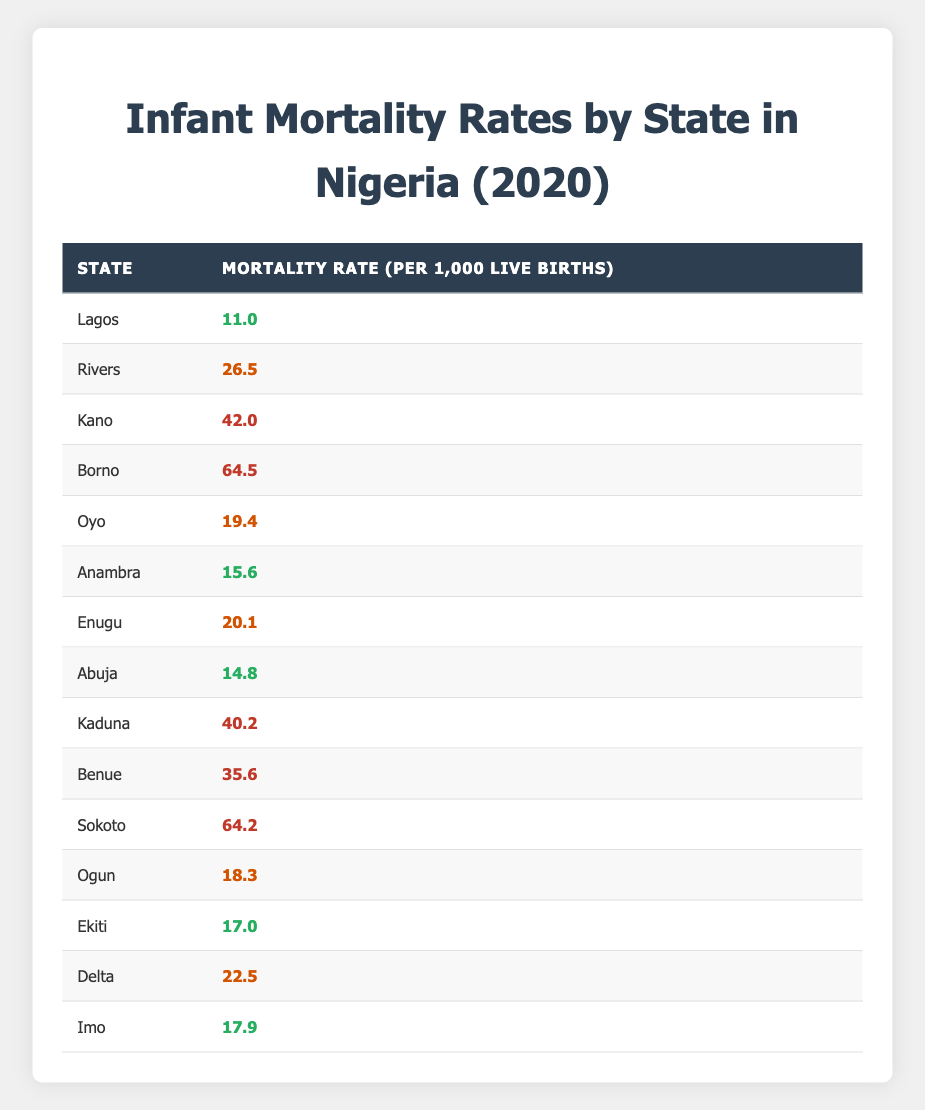What is the infant mortality rate in Lagos? The table shows that the mortality rate for Lagos is listed as 11.0 per 1,000 live births.
Answer: 11.0 Which state has the highest infant mortality rate? The state with the highest mortality rate is Borno, with a rate of 64.5 per 1,000 live births.
Answer: Borno What is the infant mortality rate of Rivers compared to Kaduna? Rivers has a mortality rate of 26.5, while Kaduna has a higher rate of 40.2. Thus, Kaduna's rate is higher than Rivers'.
Answer: Higher What is the difference between the infant mortality rates of Anambra and Ekiti? Anambra's rate is 15.6, and Ekiti's rate is 17.0. The difference is 17.0 - 15.6 = 1.4.
Answer: 1.4 How many states have a mortality rate above 40? The states with a mortality rate above 40 are Kano, Borno, Kaduna, Benue, and Sokoto. Total states with high rates = 5.
Answer: 5 What is the average infant mortality rate across all states listed in the table? To find the average, we first sum all the rates: (11.0 + 26.5 + 42.0 + 64.5 + 19.4 + 15.6 + 20.1 + 14.8 + 40.2 + 35.6 + 64.2 + 18.3 + 17.0 + 22.5 + 17.9) =  422.2. There are 15 states, so the average is 422.2 / 15 ≈ 28.15.
Answer: 28.15 Which state has a lower infant mortality rate: Ogun or Oyo? Ogun has a rate of 18.3, while Oyo has a higher rate of 19.4. Therefore, Ogun has a lower rate.
Answer: Ogun Is the infant mortality rate in Abuja higher than the national average? First, we need the average: the average calculated is 28.15. Abuja's rate is 14.8, which is lower than 28.15. Hence, it is not higher.
Answer: No Which states have a mortality rate classified as low (less than 20)? The states with low mortality rates (less than 20) are Lagos (11.0), Anambra (15.6), Abuja (14.8), Ekiti (17.0), and Imo (17.9). Count of such states = 5.
Answer: 5 What can be concluded about the trends in infant mortality based on the provided data? The data shows that Borno and Sokoto have the highest rates, indicating significant regional disparities in infant mortality across Nigeria, with several states having high mortality rates that require focused health interventions.
Answer: Regional disparities exist 